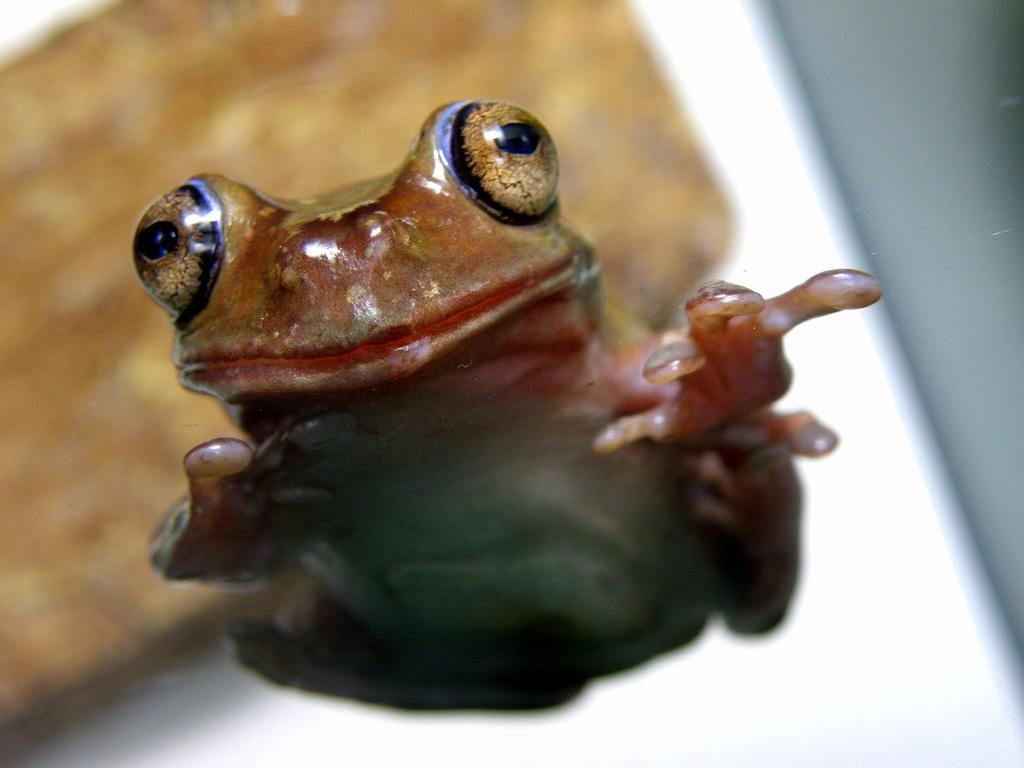What is the main subject of the image? There is a frog in the image. Can you describe the background of the image? The background of the image is blurred. What type of sound can be heard coming from the frog in the image? There is no sound present in the image, as it is a still image and not a video or audio recording. 